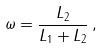Convert formula to latex. <formula><loc_0><loc_0><loc_500><loc_500>\omega = \frac { L _ { 2 } } { L _ { 1 } + L _ { 2 } } \, ,</formula> 